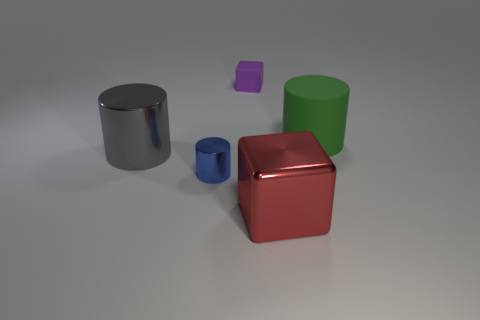What number of other objects are the same material as the green cylinder?
Your response must be concise. 1. There is a small object that is in front of the tiny purple matte object; are there any metallic objects right of it?
Provide a succinct answer. Yes. What is the material of the object that is behind the gray metallic cylinder and in front of the rubber cube?
Your answer should be very brief. Rubber. What is the shape of the red thing that is the same material as the tiny blue thing?
Ensure brevity in your answer.  Cube. Is the large thing that is to the left of the tiny purple block made of the same material as the big red object?
Ensure brevity in your answer.  Yes. What is the material of the big cylinder that is on the left side of the green rubber object?
Offer a very short reply. Metal. What is the size of the cube behind the rubber object in front of the purple matte cube?
Your answer should be very brief. Small. What number of matte blocks have the same size as the red object?
Ensure brevity in your answer.  0. Are there any big green matte objects to the left of the rubber cylinder?
Provide a succinct answer. No. The object that is both in front of the gray shiny cylinder and on the right side of the tiny blue object is what color?
Give a very brief answer. Red. 